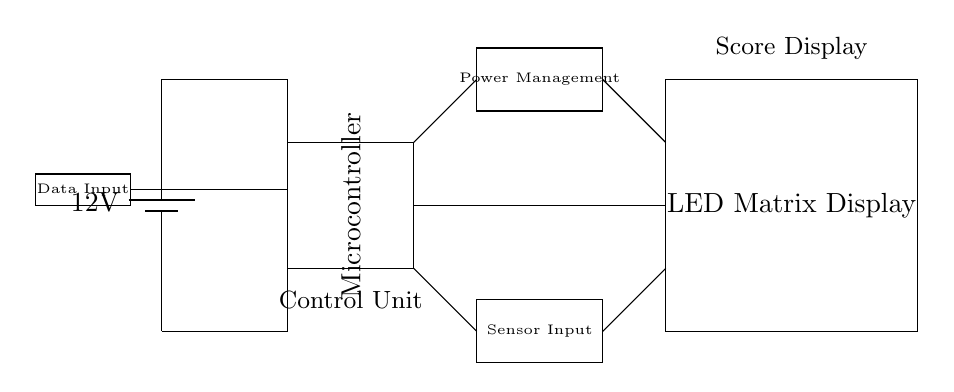What is the voltage supplied in this circuit? The voltage supplied is 12 volts, as indicated by the battery symbol labeled with "12V." This represents the potential difference that powers the entire circuit.
Answer: 12 volts What component receives data input? The component that receives data input is labeled as "Data Input," which is represented by a small rectangle to the left of the microcontroller and is connected to it. This indicates that data flows from this input into the control unit of the circuit.
Answer: Data Input How many main components are shown in the circuit? The circuit contains three main components: the microcontroller, LED matrix display, and power management system. A count can be quickly made by identifying the distinct boxes representing each component in the diagram.
Answer: Three What does the power management unit connect to? The power management unit connects to both the microcontroller and the LED matrix display, facilitating the distribution of power from the battery to these components. This connection is indicated by the lines drawn from the power management to each component in the circuit.
Answer: Microcontroller and LED Matrix Display What type of display is used in this circuit? The display used in this circuit is an LED matrix display, as indicated by the label on the rectangular box in the diagram. This type of display is typically used for visual output in scorekeeping applications in sports arenas.
Answer: LED Matrix Display Where is the sensor input located in relation to the microcontroller? The sensor input is located below the microcontroller. It is represented by its own rectangle and is connected to the microcontroller, indicating that it provides data to the control unit from the sensors.
Answer: Below the microcontroller What is the primary function of the microcontroller in this circuit? The primary function of the microcontroller is to control the overall operation of the scoreboard display system by processing data inputs and managing outputs to the LED matrix display. This function is inferred from its role as the control unit indicated in the circuit diagram.
Answer: Control the scoreboard display 